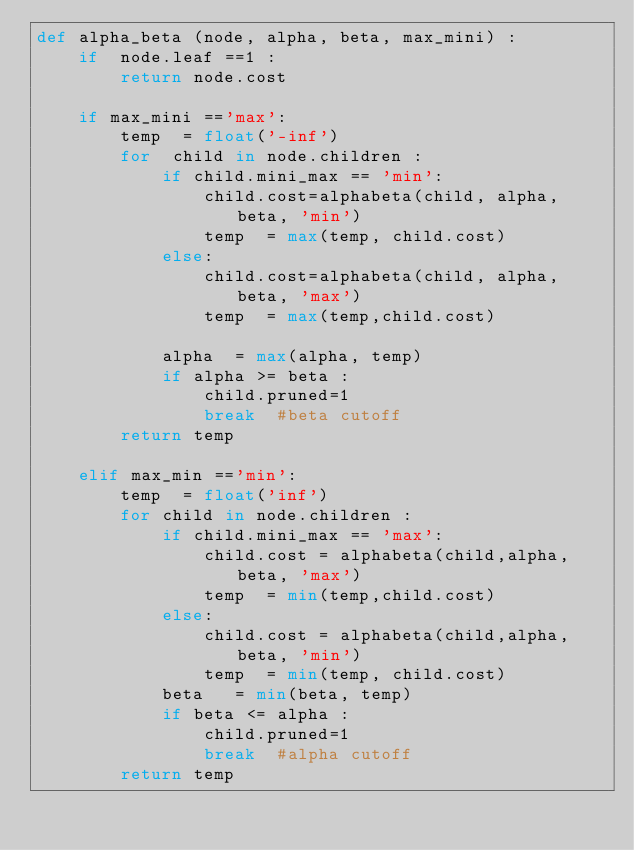Convert code to text. <code><loc_0><loc_0><loc_500><loc_500><_Python_>def alpha_beta (node, alpha, beta, max_mini) :
    if  node.leaf ==1 :
        return node.cost

    if max_mini =='max':
        temp  = float('-inf')
        for  child in node.children :
			if child.mini_max == 'min':
                child.cost=alphabeta(child, alpha, beta, 'min')
            	temp  = max(temp, child.cost)
			else:
                child.cost=alphabeta(child, alpha, beta, 'max')
				temp  = max(temp,child.cost)
				
            alpha  = max(alpha, temp)
            if alpha >= beta :
                child.pruned=1
                break  #beta cutoff 
        return temp

    elif max_min =='min':
        temp  = float('inf')
        for child in node.children :
			if child.mini_max == 'max':
                child.cost = alphabeta(child,alpha, beta, 'max')
            	temp  = min(temp,child.cost)
			else:
                child.cost = alphabeta(child,alpha, beta, 'min')
				temp  = min(temp, child.cost)
            beta   = min(beta, temp)
            if beta <= alpha :
                child.pruned=1
                break  #alpha cutoff
        return temp
</code> 